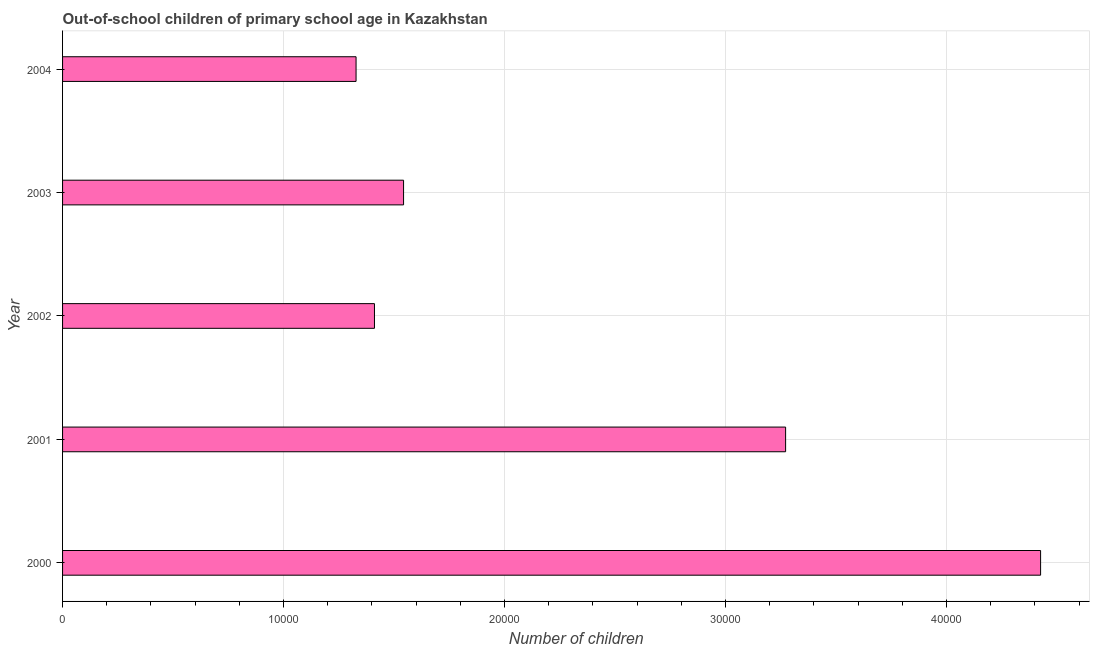What is the title of the graph?
Make the answer very short. Out-of-school children of primary school age in Kazakhstan. What is the label or title of the X-axis?
Your response must be concise. Number of children. What is the number of out-of-school children in 2000?
Provide a succinct answer. 4.43e+04. Across all years, what is the maximum number of out-of-school children?
Ensure brevity in your answer.  4.43e+04. Across all years, what is the minimum number of out-of-school children?
Make the answer very short. 1.33e+04. What is the sum of the number of out-of-school children?
Provide a succinct answer. 1.20e+05. What is the difference between the number of out-of-school children in 2001 and 2003?
Offer a terse response. 1.73e+04. What is the average number of out-of-school children per year?
Provide a short and direct response. 2.40e+04. What is the median number of out-of-school children?
Provide a short and direct response. 1.54e+04. In how many years, is the number of out-of-school children greater than 42000 ?
Keep it short and to the point. 1. Do a majority of the years between 2001 and 2004 (inclusive) have number of out-of-school children greater than 44000 ?
Ensure brevity in your answer.  No. What is the ratio of the number of out-of-school children in 2001 to that in 2003?
Offer a terse response. 2.12. Is the number of out-of-school children in 2000 less than that in 2004?
Your answer should be compact. No. What is the difference between the highest and the second highest number of out-of-school children?
Provide a short and direct response. 1.15e+04. What is the difference between the highest and the lowest number of out-of-school children?
Provide a short and direct response. 3.10e+04. How many bars are there?
Provide a short and direct response. 5. Are all the bars in the graph horizontal?
Your answer should be compact. Yes. How many years are there in the graph?
Make the answer very short. 5. What is the difference between two consecutive major ticks on the X-axis?
Your answer should be very brief. 10000. What is the Number of children of 2000?
Keep it short and to the point. 4.43e+04. What is the Number of children of 2001?
Ensure brevity in your answer.  3.27e+04. What is the Number of children in 2002?
Provide a succinct answer. 1.41e+04. What is the Number of children in 2003?
Offer a terse response. 1.54e+04. What is the Number of children of 2004?
Your answer should be very brief. 1.33e+04. What is the difference between the Number of children in 2000 and 2001?
Offer a terse response. 1.15e+04. What is the difference between the Number of children in 2000 and 2002?
Make the answer very short. 3.01e+04. What is the difference between the Number of children in 2000 and 2003?
Offer a terse response. 2.88e+04. What is the difference between the Number of children in 2000 and 2004?
Provide a succinct answer. 3.10e+04. What is the difference between the Number of children in 2001 and 2002?
Provide a short and direct response. 1.86e+04. What is the difference between the Number of children in 2001 and 2003?
Keep it short and to the point. 1.73e+04. What is the difference between the Number of children in 2001 and 2004?
Ensure brevity in your answer.  1.94e+04. What is the difference between the Number of children in 2002 and 2003?
Give a very brief answer. -1316. What is the difference between the Number of children in 2002 and 2004?
Offer a terse response. 833. What is the difference between the Number of children in 2003 and 2004?
Your response must be concise. 2149. What is the ratio of the Number of children in 2000 to that in 2001?
Provide a succinct answer. 1.35. What is the ratio of the Number of children in 2000 to that in 2002?
Make the answer very short. 3.14. What is the ratio of the Number of children in 2000 to that in 2003?
Provide a succinct answer. 2.87. What is the ratio of the Number of children in 2000 to that in 2004?
Provide a short and direct response. 3.33. What is the ratio of the Number of children in 2001 to that in 2002?
Keep it short and to the point. 2.32. What is the ratio of the Number of children in 2001 to that in 2003?
Give a very brief answer. 2.12. What is the ratio of the Number of children in 2001 to that in 2004?
Provide a short and direct response. 2.46. What is the ratio of the Number of children in 2002 to that in 2003?
Provide a short and direct response. 0.92. What is the ratio of the Number of children in 2002 to that in 2004?
Offer a very short reply. 1.06. What is the ratio of the Number of children in 2003 to that in 2004?
Your answer should be compact. 1.16. 